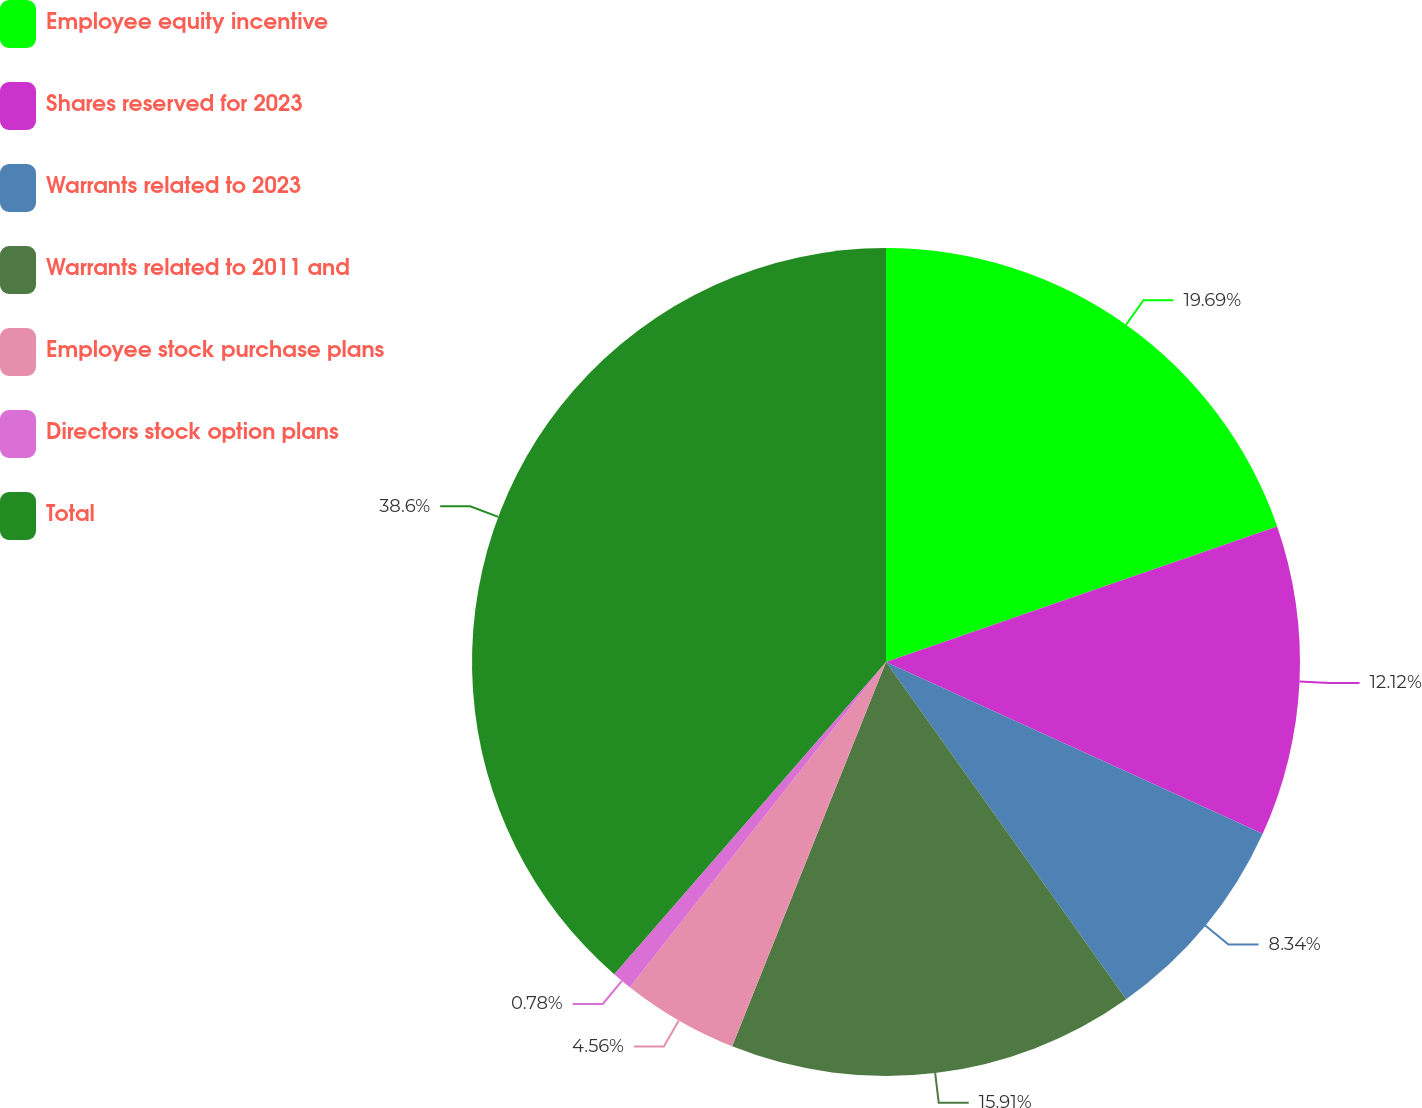Convert chart to OTSL. <chart><loc_0><loc_0><loc_500><loc_500><pie_chart><fcel>Employee equity incentive<fcel>Shares reserved for 2023<fcel>Warrants related to 2023<fcel>Warrants related to 2011 and<fcel>Employee stock purchase plans<fcel>Directors stock option plans<fcel>Total<nl><fcel>19.69%<fcel>12.12%<fcel>8.34%<fcel>15.91%<fcel>4.56%<fcel>0.78%<fcel>38.6%<nl></chart> 